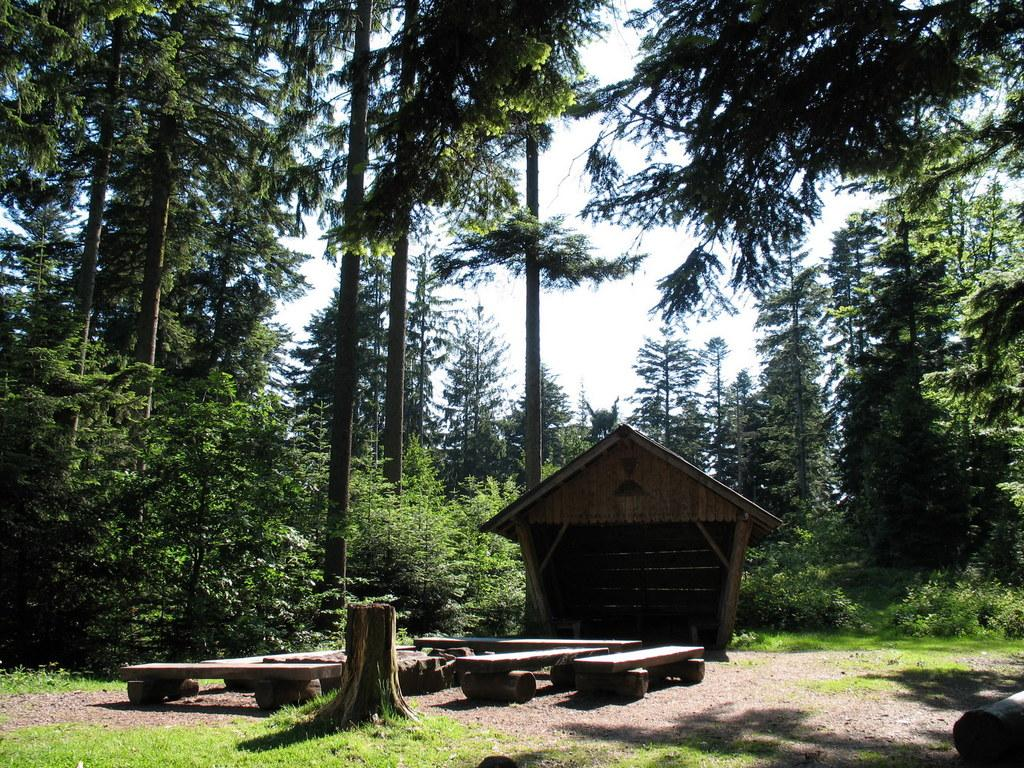What type of vegetation is present in the image? There is grass, plants, and trees in the image. What type of seating can be seen in the image? There are benches in the image. What part of the tree is visible in the image? There is a tree trunk in the image. What provides cover from the sun in the image? There is shade in the image. Can you describe the sky in the image? The sky is visible in the background of the image. What type of sweater is the tree wearing in the image? There is no sweater present in the image, as trees do not wear clothing. 